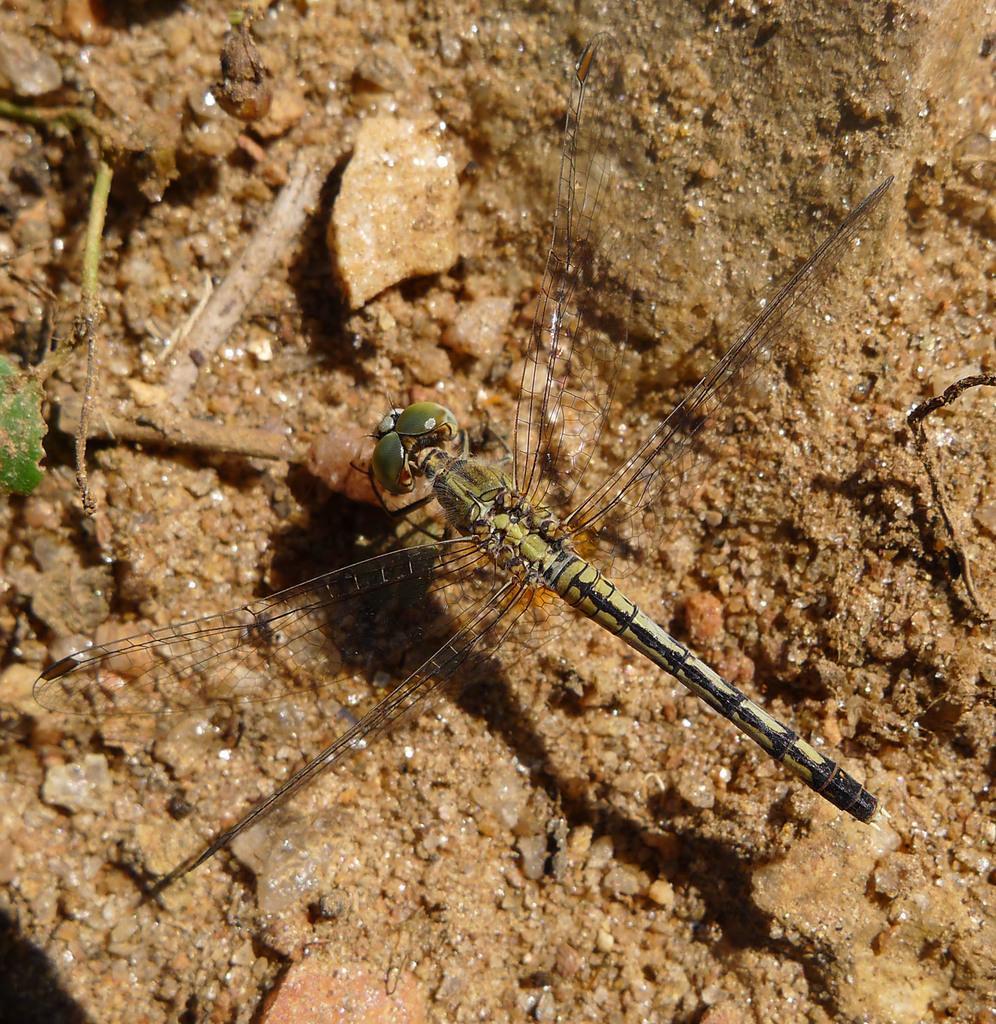Can you describe this image briefly? In the middle of this image, there is an insect having wings, standing on a stone which is on the ground, on which there are stones. On the left side, there is a green colored leaves. 